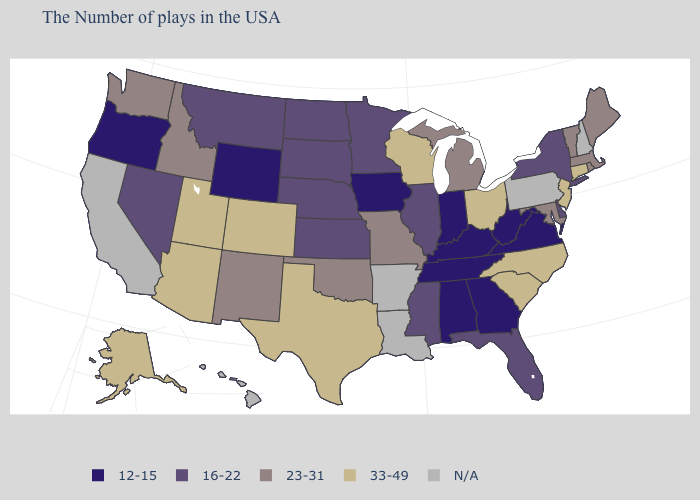What is the value of Maryland?
Concise answer only. 23-31. Does Iowa have the lowest value in the USA?
Quick response, please. Yes. What is the value of Illinois?
Write a very short answer. 16-22. What is the value of Missouri?
Give a very brief answer. 23-31. Name the states that have a value in the range 16-22?
Answer briefly. New York, Delaware, Florida, Illinois, Mississippi, Minnesota, Kansas, Nebraska, South Dakota, North Dakota, Montana, Nevada. Which states have the lowest value in the USA?
Answer briefly. Virginia, West Virginia, Georgia, Kentucky, Indiana, Alabama, Tennessee, Iowa, Wyoming, Oregon. What is the value of North Carolina?
Short answer required. 33-49. Which states have the highest value in the USA?
Keep it brief. Connecticut, New Jersey, North Carolina, South Carolina, Ohio, Wisconsin, Texas, Colorado, Utah, Arizona, Alaska. Which states have the highest value in the USA?
Give a very brief answer. Connecticut, New Jersey, North Carolina, South Carolina, Ohio, Wisconsin, Texas, Colorado, Utah, Arizona, Alaska. What is the lowest value in the USA?
Short answer required. 12-15. Among the states that border Mississippi , which have the highest value?
Give a very brief answer. Alabama, Tennessee. Name the states that have a value in the range 16-22?
Give a very brief answer. New York, Delaware, Florida, Illinois, Mississippi, Minnesota, Kansas, Nebraska, South Dakota, North Dakota, Montana, Nevada. How many symbols are there in the legend?
Quick response, please. 5. Among the states that border Wisconsin , does Michigan have the highest value?
Be succinct. Yes. 